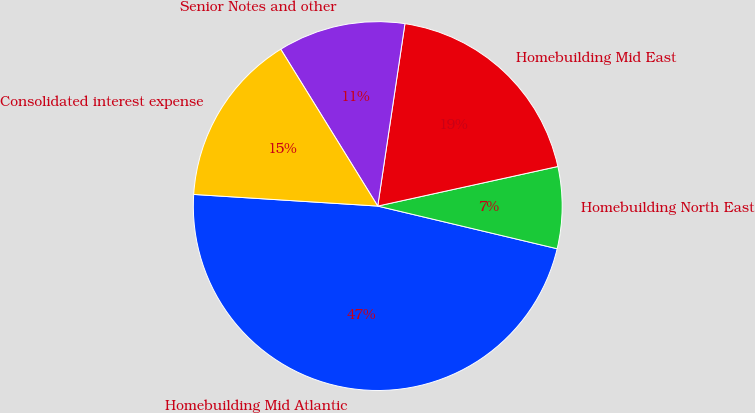Convert chart to OTSL. <chart><loc_0><loc_0><loc_500><loc_500><pie_chart><fcel>Homebuilding Mid Atlantic<fcel>Homebuilding North East<fcel>Homebuilding Mid East<fcel>Senior Notes and other<fcel>Consolidated interest expense<nl><fcel>47.29%<fcel>7.16%<fcel>19.2%<fcel>11.17%<fcel>15.18%<nl></chart> 